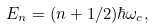<formula> <loc_0><loc_0><loc_500><loc_500>E _ { n } = ( n + 1 / 2 ) \hbar { \omega } _ { c } ,</formula> 